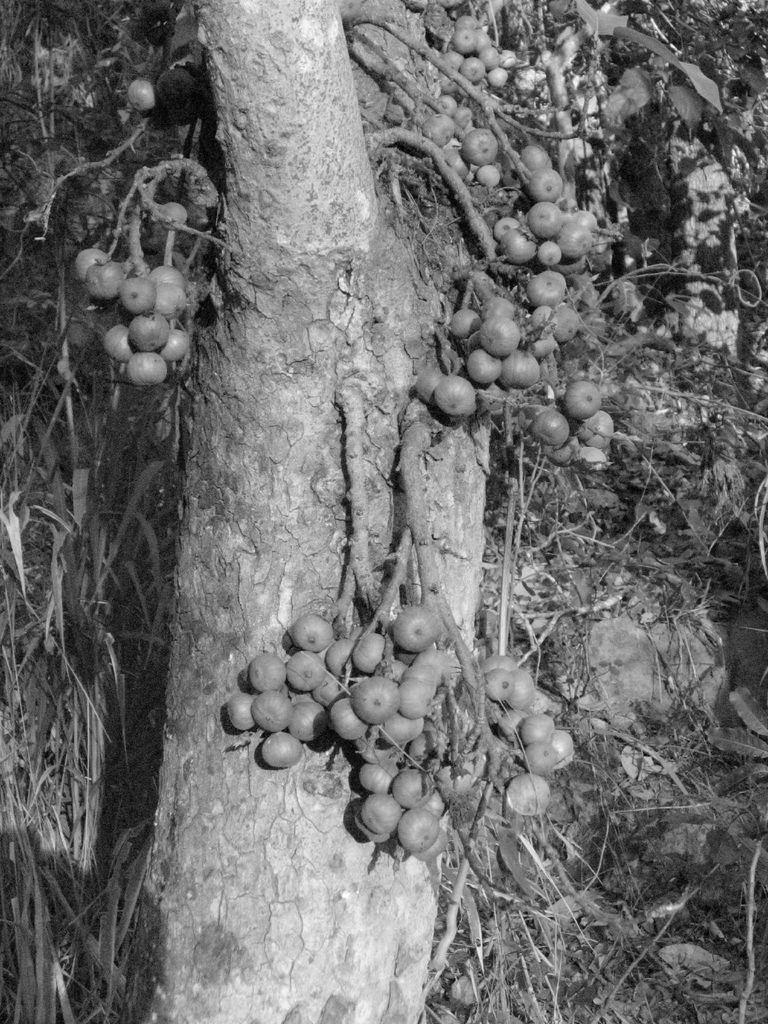What is the color scheme of the image? The image is black and white. What natural element can be seen in the image? There is a tree in the image. What is present on the tree? There are fruits on the tree. What day of the week is depicted in the image? The image does not depict a day of the week, as it is a black and white image of a tree with fruits. Can you see any ghosts in the image? There are no ghosts present in the image; it features a tree with fruits in a black and white color scheme. 